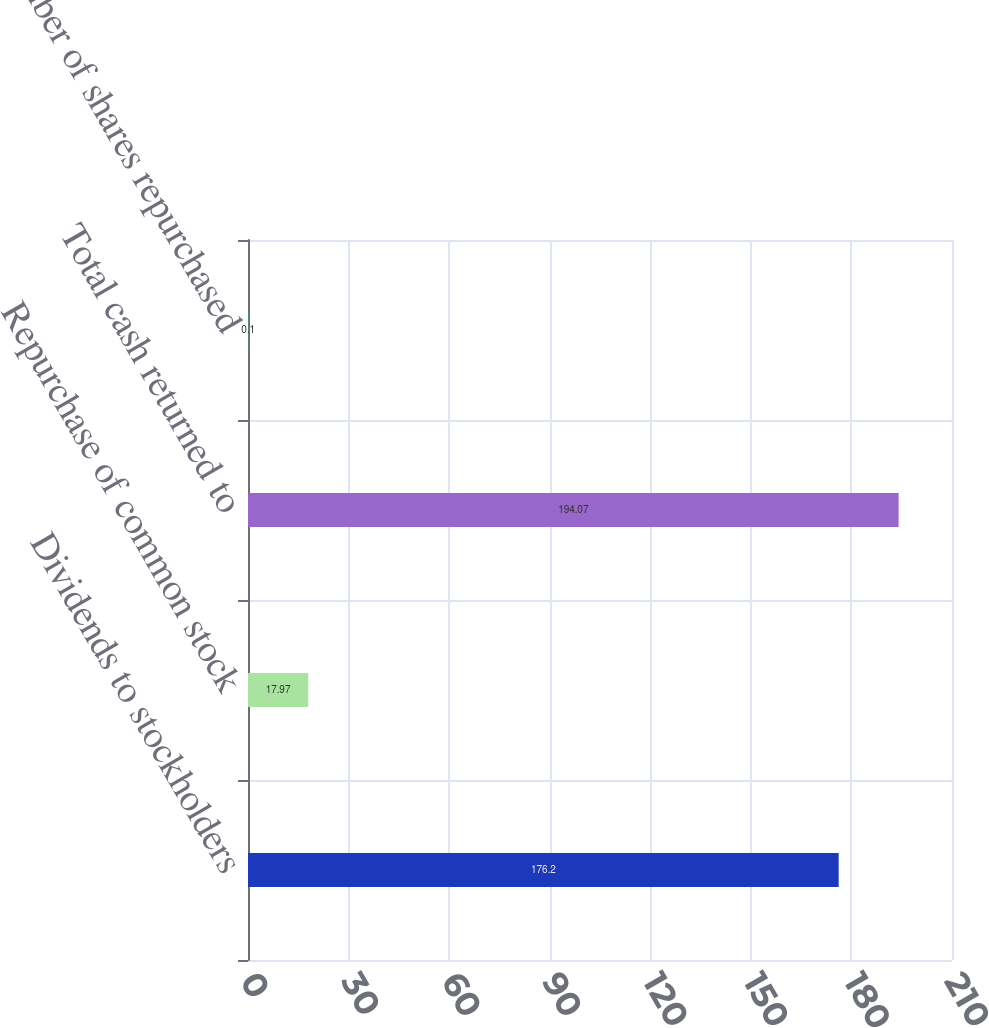<chart> <loc_0><loc_0><loc_500><loc_500><bar_chart><fcel>Dividends to stockholders<fcel>Repurchase of common stock<fcel>Total cash returned to<fcel>Number of shares repurchased<nl><fcel>176.2<fcel>17.97<fcel>194.07<fcel>0.1<nl></chart> 